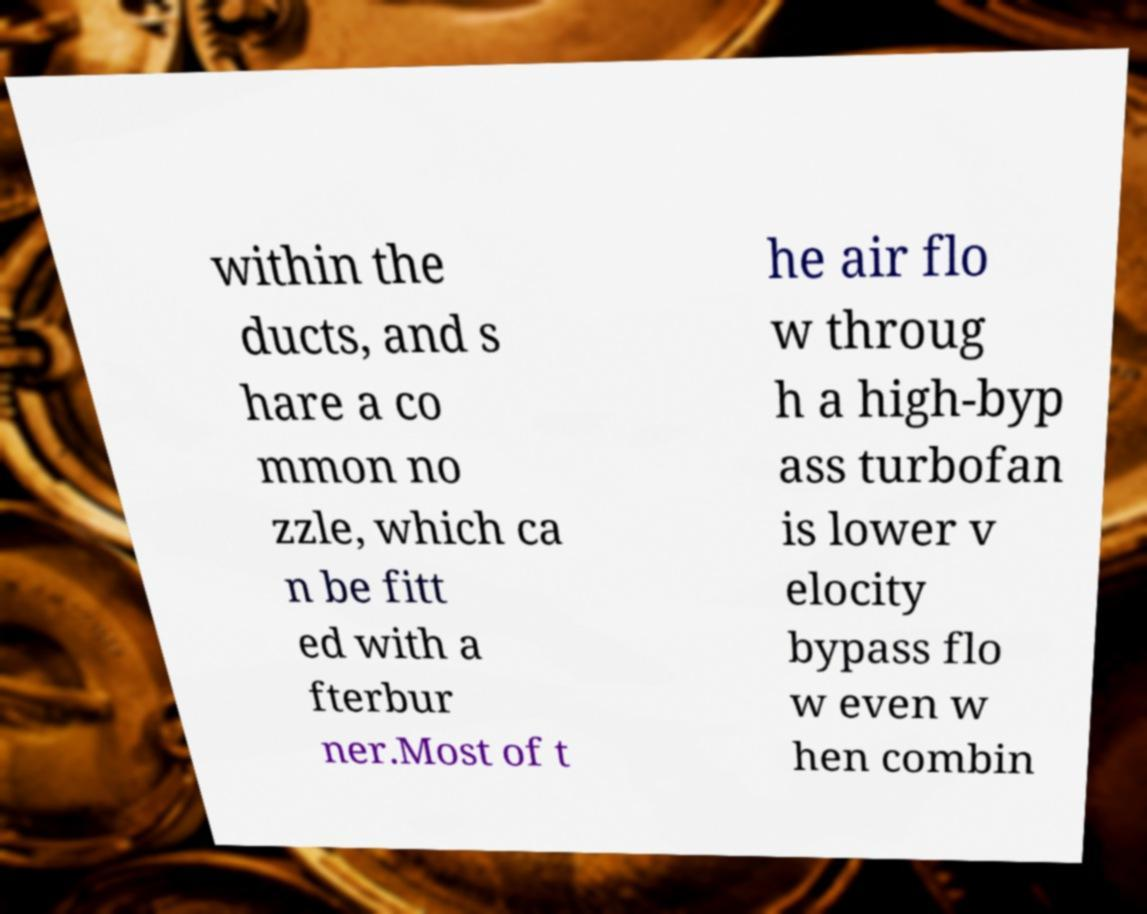Please read and relay the text visible in this image. What does it say? within the ducts, and s hare a co mmon no zzle, which ca n be fitt ed with a fterbur ner.Most of t he air flo w throug h a high-byp ass turbofan is lower v elocity bypass flo w even w hen combin 